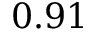<formula> <loc_0><loc_0><loc_500><loc_500>0 . 9 1</formula> 